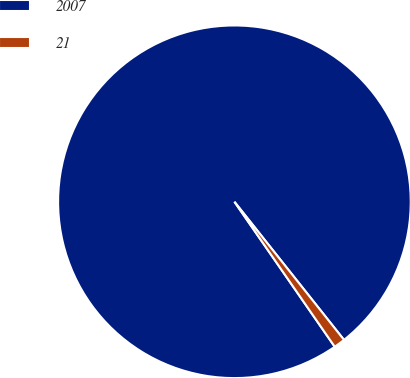<chart> <loc_0><loc_0><loc_500><loc_500><pie_chart><fcel>2007<fcel>21<nl><fcel>98.96%<fcel>1.04%<nl></chart> 